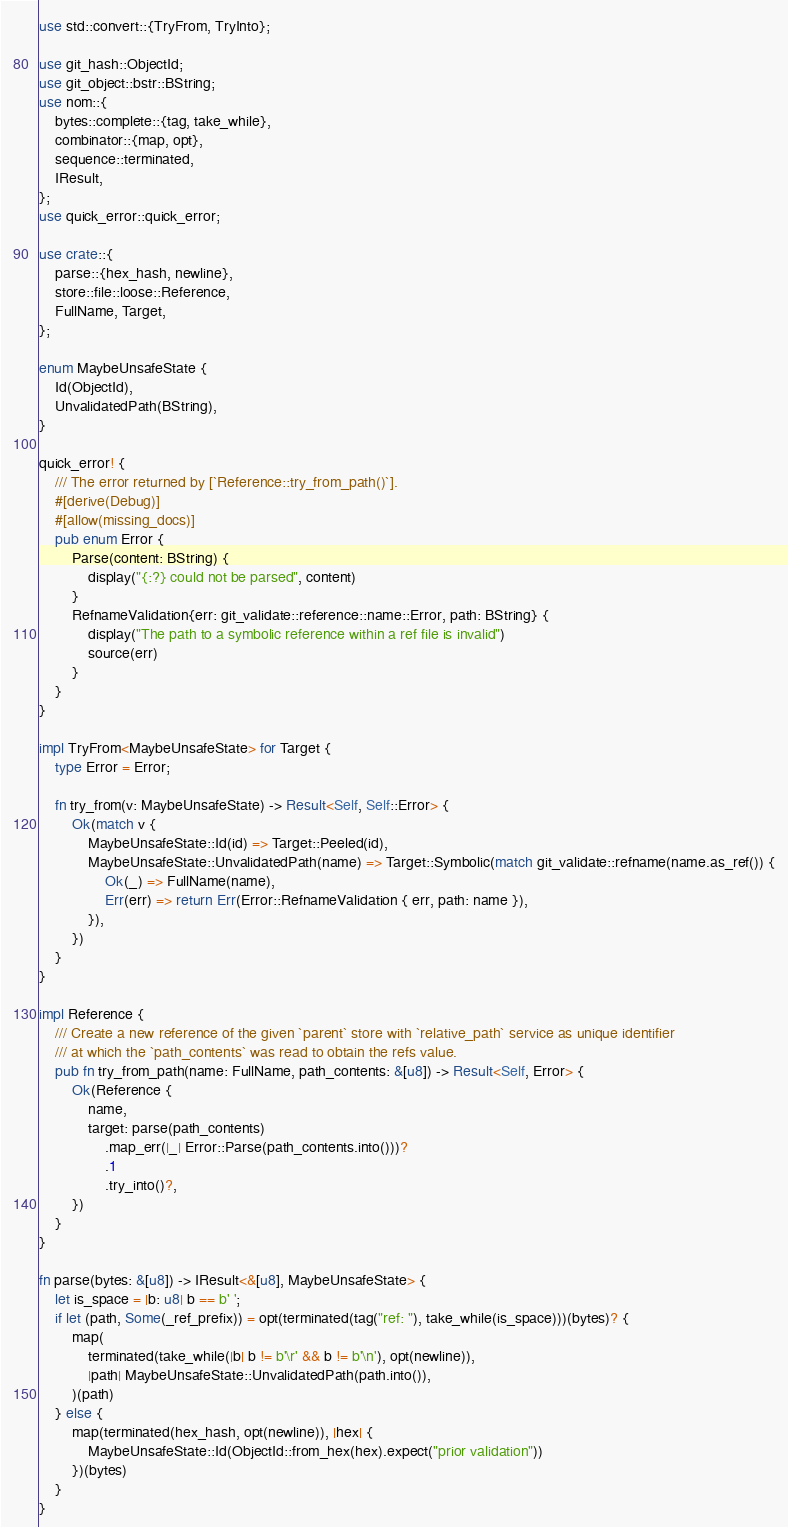Convert code to text. <code><loc_0><loc_0><loc_500><loc_500><_Rust_>use std::convert::{TryFrom, TryInto};

use git_hash::ObjectId;
use git_object::bstr::BString;
use nom::{
    bytes::complete::{tag, take_while},
    combinator::{map, opt},
    sequence::terminated,
    IResult,
};
use quick_error::quick_error;

use crate::{
    parse::{hex_hash, newline},
    store::file::loose::Reference,
    FullName, Target,
};

enum MaybeUnsafeState {
    Id(ObjectId),
    UnvalidatedPath(BString),
}

quick_error! {
    /// The error returned by [`Reference::try_from_path()`].
    #[derive(Debug)]
    #[allow(missing_docs)]
    pub enum Error {
        Parse(content: BString) {
            display("{:?} could not be parsed", content)
        }
        RefnameValidation{err: git_validate::reference::name::Error, path: BString} {
            display("The path to a symbolic reference within a ref file is invalid")
            source(err)
        }
    }
}

impl TryFrom<MaybeUnsafeState> for Target {
    type Error = Error;

    fn try_from(v: MaybeUnsafeState) -> Result<Self, Self::Error> {
        Ok(match v {
            MaybeUnsafeState::Id(id) => Target::Peeled(id),
            MaybeUnsafeState::UnvalidatedPath(name) => Target::Symbolic(match git_validate::refname(name.as_ref()) {
                Ok(_) => FullName(name),
                Err(err) => return Err(Error::RefnameValidation { err, path: name }),
            }),
        })
    }
}

impl Reference {
    /// Create a new reference of the given `parent` store with `relative_path` service as unique identifier
    /// at which the `path_contents` was read to obtain the refs value.
    pub fn try_from_path(name: FullName, path_contents: &[u8]) -> Result<Self, Error> {
        Ok(Reference {
            name,
            target: parse(path_contents)
                .map_err(|_| Error::Parse(path_contents.into()))?
                .1
                .try_into()?,
        })
    }
}

fn parse(bytes: &[u8]) -> IResult<&[u8], MaybeUnsafeState> {
    let is_space = |b: u8| b == b' ';
    if let (path, Some(_ref_prefix)) = opt(terminated(tag("ref: "), take_while(is_space)))(bytes)? {
        map(
            terminated(take_while(|b| b != b'\r' && b != b'\n'), opt(newline)),
            |path| MaybeUnsafeState::UnvalidatedPath(path.into()),
        )(path)
    } else {
        map(terminated(hex_hash, opt(newline)), |hex| {
            MaybeUnsafeState::Id(ObjectId::from_hex(hex).expect("prior validation"))
        })(bytes)
    }
}
</code> 